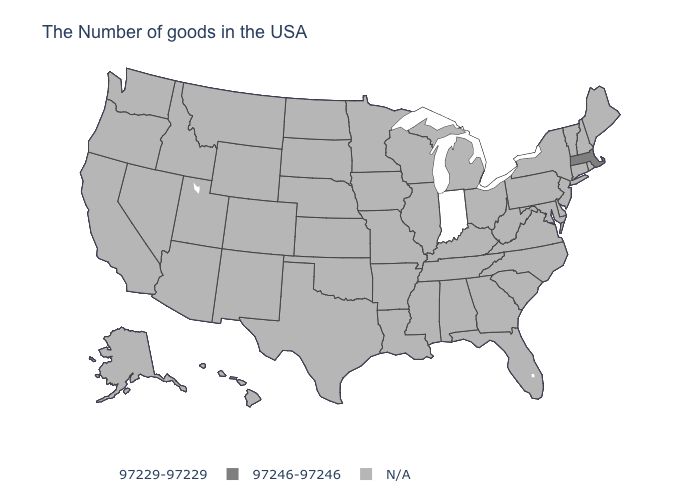Name the states that have a value in the range N/A?
Give a very brief answer. Maine, Rhode Island, New Hampshire, Vermont, Connecticut, New York, New Jersey, Delaware, Maryland, Pennsylvania, Virginia, North Carolina, South Carolina, West Virginia, Ohio, Florida, Georgia, Michigan, Kentucky, Alabama, Tennessee, Wisconsin, Illinois, Mississippi, Louisiana, Missouri, Arkansas, Minnesota, Iowa, Kansas, Nebraska, Oklahoma, Texas, South Dakota, North Dakota, Wyoming, Colorado, New Mexico, Utah, Montana, Arizona, Idaho, Nevada, California, Washington, Oregon, Alaska, Hawaii. Name the states that have a value in the range 97246-97246?
Be succinct. Massachusetts. What is the value of North Dakota?
Concise answer only. N/A. Name the states that have a value in the range N/A?
Short answer required. Maine, Rhode Island, New Hampshire, Vermont, Connecticut, New York, New Jersey, Delaware, Maryland, Pennsylvania, Virginia, North Carolina, South Carolina, West Virginia, Ohio, Florida, Georgia, Michigan, Kentucky, Alabama, Tennessee, Wisconsin, Illinois, Mississippi, Louisiana, Missouri, Arkansas, Minnesota, Iowa, Kansas, Nebraska, Oklahoma, Texas, South Dakota, North Dakota, Wyoming, Colorado, New Mexico, Utah, Montana, Arizona, Idaho, Nevada, California, Washington, Oregon, Alaska, Hawaii. What is the value of Michigan?
Quick response, please. N/A. What is the value of New Jersey?
Write a very short answer. N/A. How many symbols are there in the legend?
Write a very short answer. 3. What is the value of Wisconsin?
Answer briefly. N/A. What is the value of Mississippi?
Concise answer only. N/A. How many symbols are there in the legend?
Be succinct. 3. What is the value of Connecticut?
Quick response, please. N/A. 